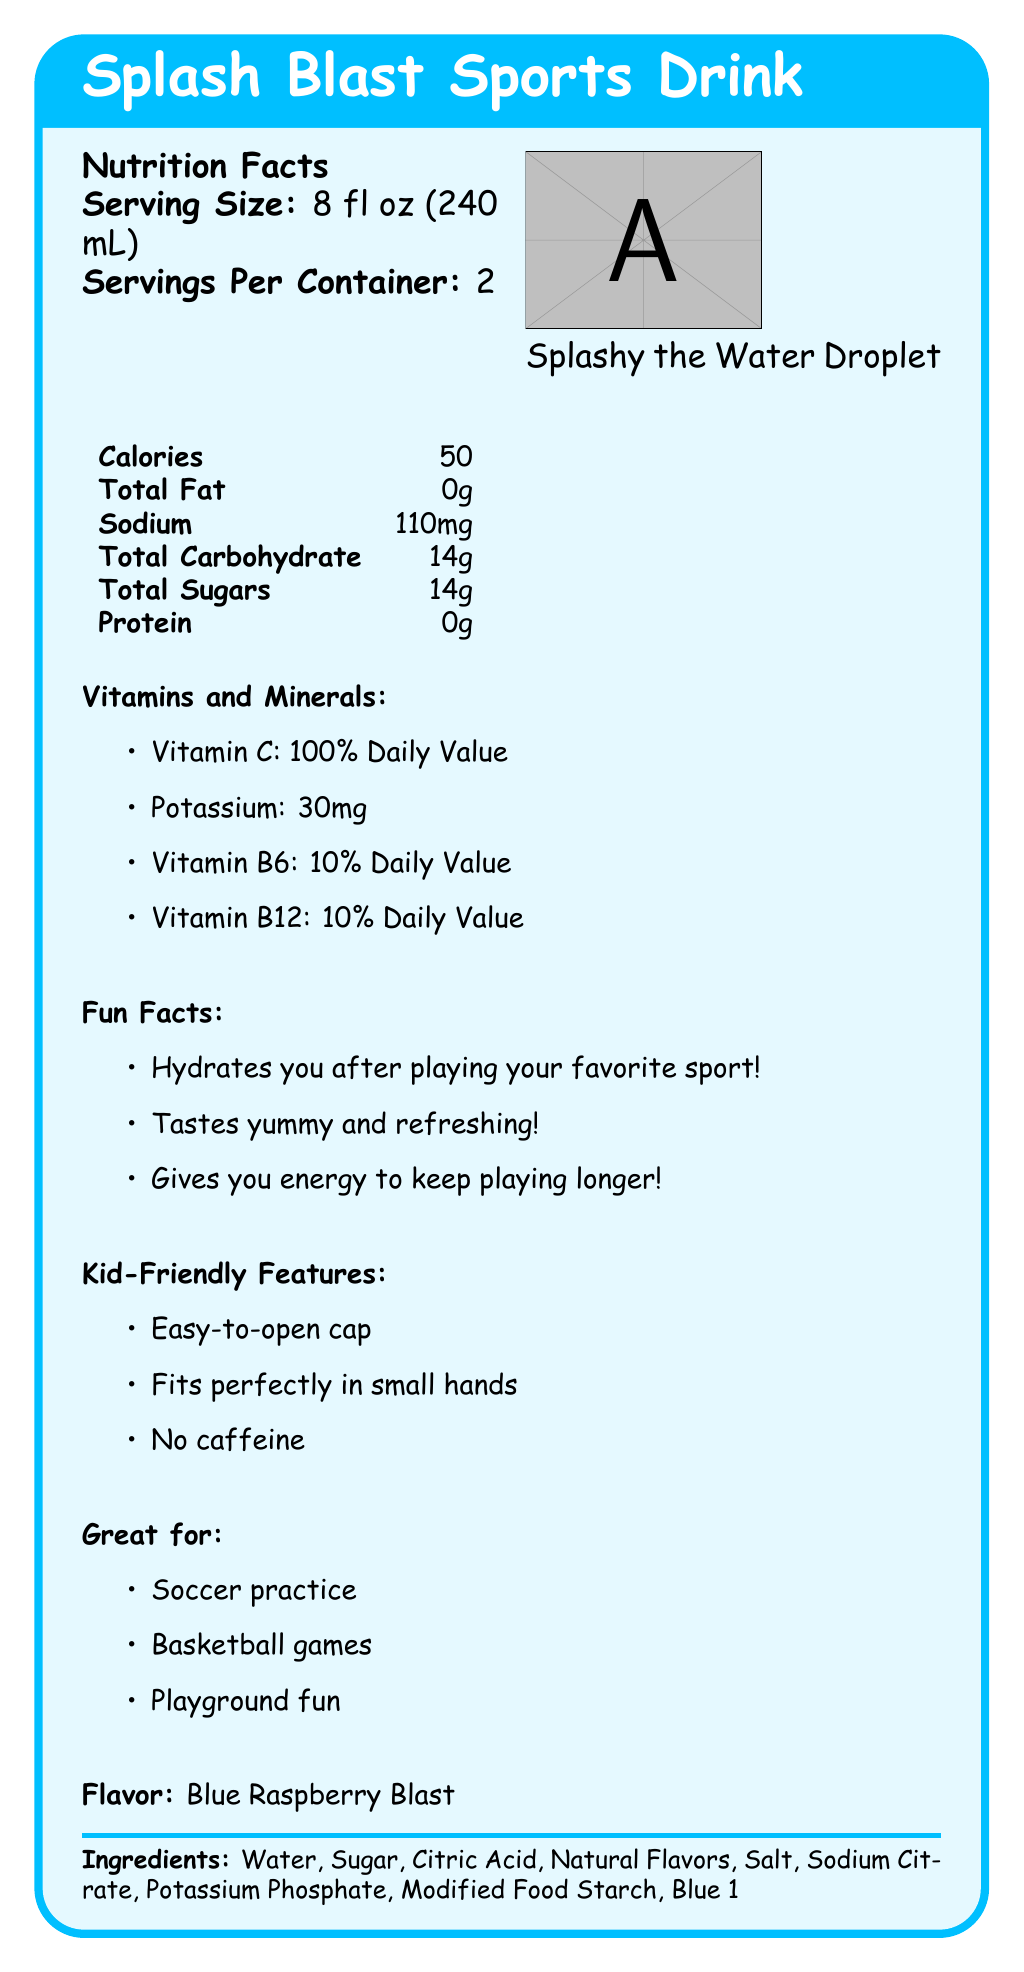what is the serving size? The serving size information is listed near the top of the Nutrition Facts, clearly stating "Serving Size: 8 fl oz (240 mL)".
Answer: 8 fl oz (240 mL) what is the total carbohydrate content per serving? The total carbohydrate content is mentioned in the document in the table under Nutrition Facts.
Answer: 14g how many calories are in one serving? The calorie content per serving is found in the table under Nutrition Facts.
Answer: 50 what color is the drink? The color code provided in the document is "#00BFFF".
Answer: #00BFFF how many servings are in the container? The document identifies "Servings Per Container: 2" near the top of the Nutrition Facts.
Answer: 2 what are some of the main vitamins and minerals in the drink? The document lists vitamins and minerals, including Vitamin C, Potassium, Vitamin B6, and Vitamin B12, along with their daily values.
Answer: Vitamin C, Potassium, Vitamin B6, Vitamin B12 what is the mascot of the drink? The document includes an image and mentions Splashy the Water Droplet as the mascot.
Answer: Splashy the Water Droplet what is the flavor of the sports drink? This information is found under the section labeled "Flavor".
Answer: Blue Raspberry Blast which feature makes this sports drink easy for kids? A. Colorful packaging B. Easy-to-open cap C. High in protein The Kid-Friendly Features section mentions "Easy-to-open cap" as one of the aspects suitable for kids.
Answer: B. Easy-to-open cap how much sodium is in one serving? The nutritional content lists sodium as 110mg per serving in the table under Nutrition Facts.
Answer: 110mg what sport is the drink great for? A. Baseball B. Soccer C. Tennis The document lists recommended activities including "Soccer practice".
Answer: B. Soccer true or false: The drink contains caffeine. The Kid-Friendly Features section mentions "No caffeine".
Answer: False what ingredient gives the drink its blue color? "Blue 1" is listed at the end of the ingredients section.
Answer: Blue 1 how many calories are there in the entire container? Since there are 2 servings per container and each serving has 50 calories, the total calories for the entire container is 50 * 2 = 100.
Answer: 100 why might this drink be good for playing sports? The Fun Facts section lists these benefits: "Hydrates you after playing your favorite sport!", "Tastes yummy and refreshing!", and "Gives you energy to keep playing longer!"
Answer: It hydrates, tastes refreshing, and provides energy. what vitamins are 100% of the daily value? The document lists Vitamin C as providing 100% of the daily value.
Answer: Vitamin C describe the main idea of the document. This detailed description encompasses all sections of the document, summarizing the health, enjoyment, and utility features of the sports drink.
Answer: The document provides detailed information about Splash Blast Sports Drink, including nutrition facts, ingredients, kid-friendly features, fun facts, and recommended activities. It highlights the drink as an enjoyable and hydrating option for active kids, notable for its Blue Raspberry Blast flavor, vibrant color, and easy-to-use packaging. who should avoid drinking this sports drink? The document does not provide information on who should avoid drinking the sports drink.
Answer: Cannot be determined 